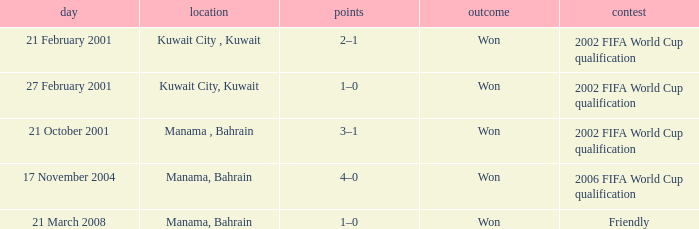Help me parse the entirety of this table. {'header': ['day', 'location', 'points', 'outcome', 'contest'], 'rows': [['21 February 2001', 'Kuwait City , Kuwait', '2–1', 'Won', '2002 FIFA World Cup qualification'], ['27 February 2001', 'Kuwait City, Kuwait', '1–0', 'Won', '2002 FIFA World Cup qualification'], ['21 October 2001', 'Manama , Bahrain', '3–1', 'Won', '2002 FIFA World Cup qualification'], ['17 November 2004', 'Manama, Bahrain', '4–0', 'Won', '2006 FIFA World Cup qualification'], ['21 March 2008', 'Manama, Bahrain', '1–0', 'Won', 'Friendly']]} On which date was the 2006 FIFA World Cup Qualification in Manama, Bahrain? 17 November 2004. 